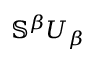<formula> <loc_0><loc_0><loc_500><loc_500>\mathbb { S } ^ { \beta } U _ { \beta }</formula> 